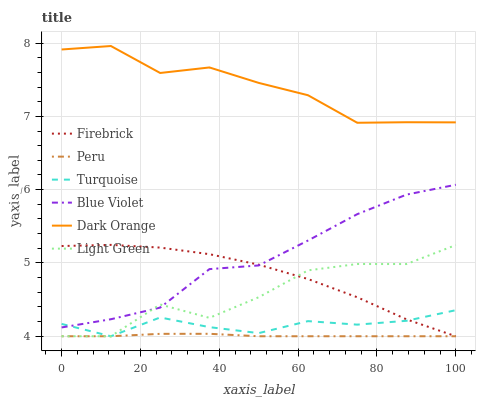Does Peru have the minimum area under the curve?
Answer yes or no. Yes. Does Dark Orange have the maximum area under the curve?
Answer yes or no. Yes. Does Turquoise have the minimum area under the curve?
Answer yes or no. No. Does Turquoise have the maximum area under the curve?
Answer yes or no. No. Is Peru the smoothest?
Answer yes or no. Yes. Is Light Green the roughest?
Answer yes or no. Yes. Is Turquoise the smoothest?
Answer yes or no. No. Is Turquoise the roughest?
Answer yes or no. No. Does Turquoise have the lowest value?
Answer yes or no. Yes. Does Blue Violet have the lowest value?
Answer yes or no. No. Does Dark Orange have the highest value?
Answer yes or no. Yes. Does Turquoise have the highest value?
Answer yes or no. No. Is Blue Violet less than Dark Orange?
Answer yes or no. Yes. Is Dark Orange greater than Peru?
Answer yes or no. Yes. Does Light Green intersect Peru?
Answer yes or no. Yes. Is Light Green less than Peru?
Answer yes or no. No. Is Light Green greater than Peru?
Answer yes or no. No. Does Blue Violet intersect Dark Orange?
Answer yes or no. No. 